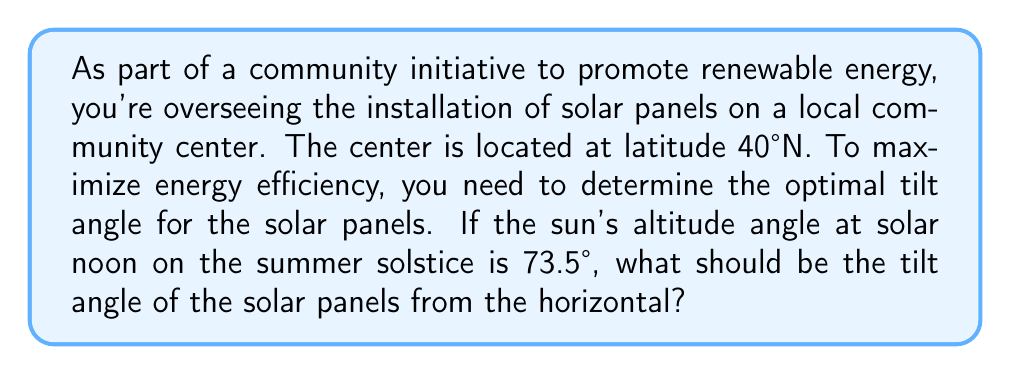Can you answer this question? Let's approach this step-by-step:

1) The optimal tilt angle for solar panels is generally equal to the latitude of the location. This is because it allows the panels to be perpendicular to the sun's rays at solar noon during the equinoxes.

2) However, we can fine-tune this angle by considering the sun's position at the summer solstice, which is when the sun is at its highest point in the sky.

3) Let's define our variables:
   $\theta$ = optimal tilt angle from horizontal
   $\alpha$ = sun's altitude angle at solar noon on summer solstice
   $\phi$ = latitude

4) We know that $\phi = 40°$ and $\alpha = 73.5°$

5) The relationship between these angles is:

   $$ \theta = 90° - \alpha + (90° - \phi) $$

6) This equation accounts for the fact that we want the panels tilted slightly less than the latitude to capture more energy during summer months.

7) Substituting our known values:

   $$ \theta = 90° - 73.5° + (90° - 40°) $$
   $$ \theta = 16.5° + 50° $$
   $$ \theta = 66.5° $$

8) Therefore, the optimal tilt angle for the solar panels is 66.5° from the horizontal.

This angle will provide a good balance, maximizing energy capture during summer while still performing well year-round.
Answer: 66.5° 